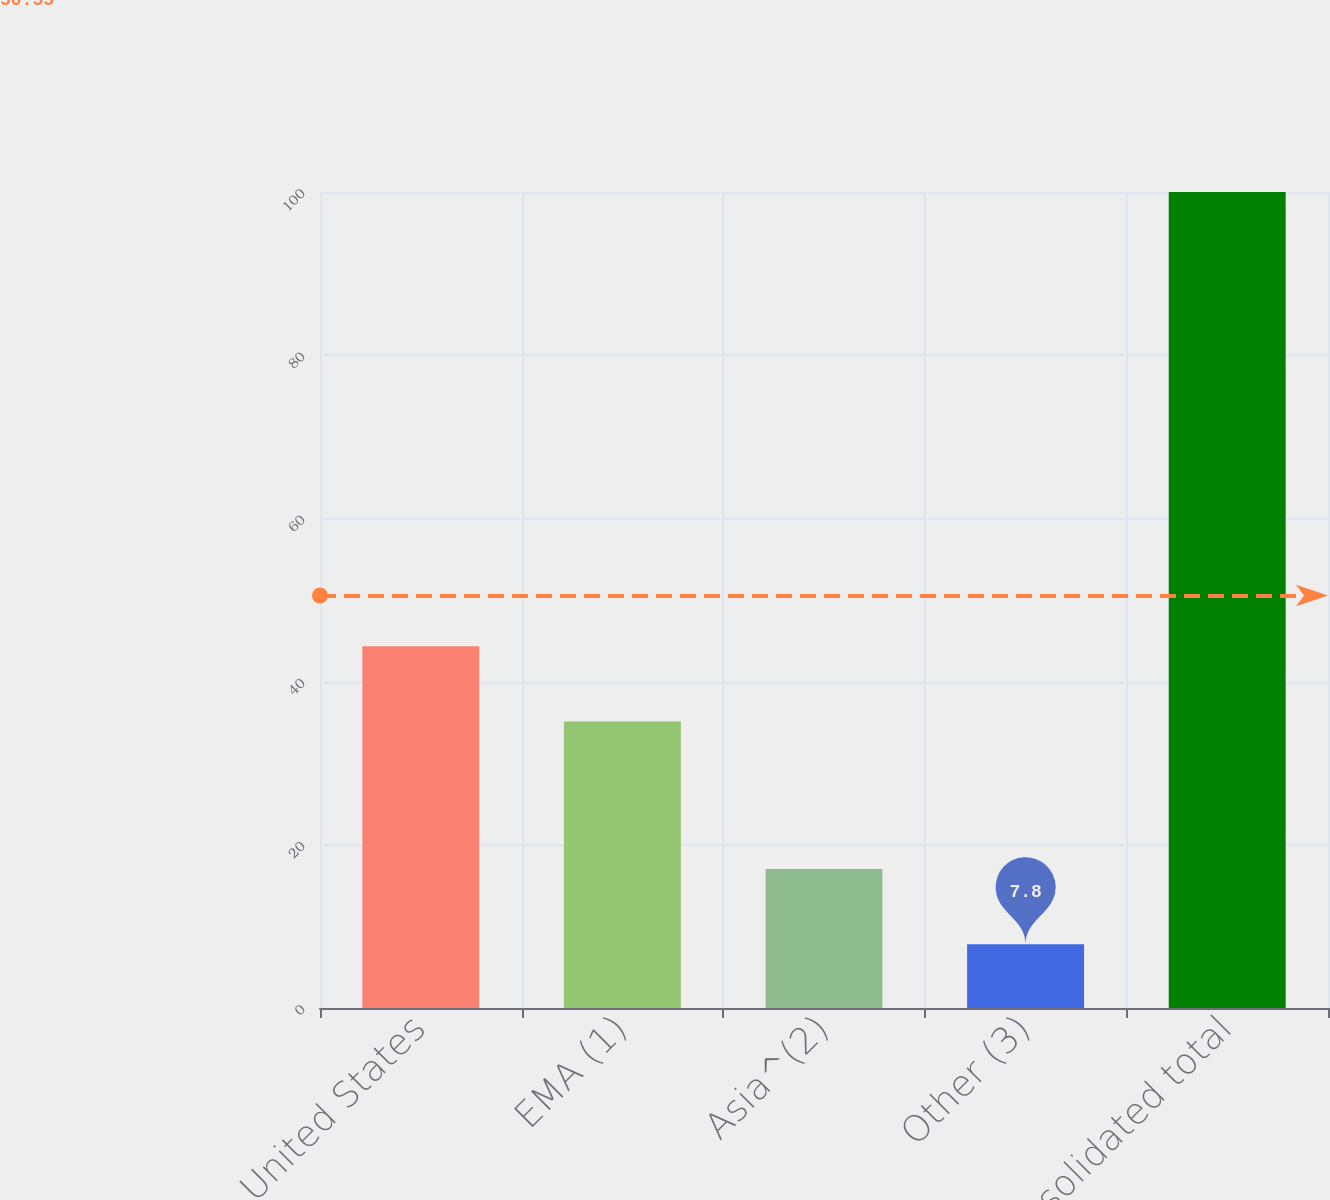Convert chart to OTSL. <chart><loc_0><loc_0><loc_500><loc_500><bar_chart><fcel>United States<fcel>EMA (1)<fcel>Asia^(2)<fcel>Other (3)<fcel>Consolidated total<nl><fcel>44.32<fcel>35.1<fcel>17.02<fcel>7.8<fcel>100<nl></chart> 